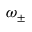<formula> <loc_0><loc_0><loc_500><loc_500>\omega _ { \pm }</formula> 